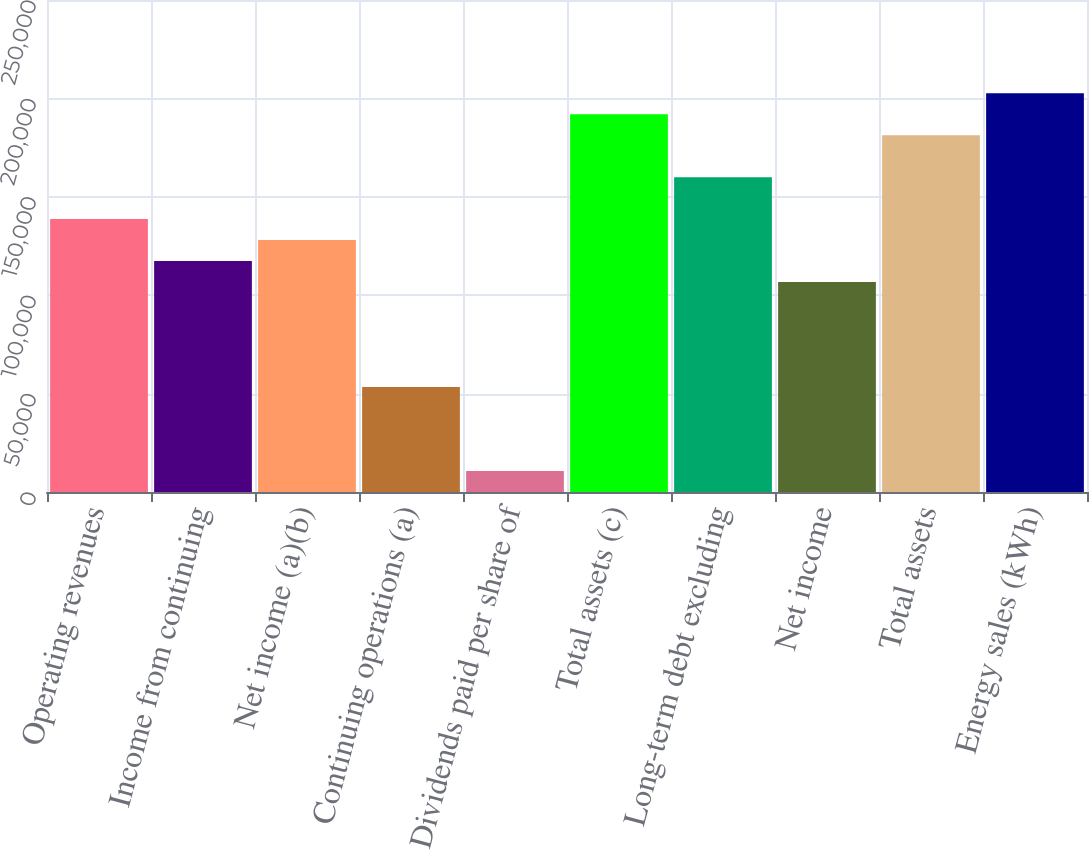Convert chart. <chart><loc_0><loc_0><loc_500><loc_500><bar_chart><fcel>Operating revenues<fcel>Income from continuing<fcel>Net income (a)(b)<fcel>Continuing operations (a)<fcel>Dividends paid per share of<fcel>Total assets (c)<fcel>Long-term debt excluding<fcel>Net income<fcel>Total assets<fcel>Energy sales (kWh)<nl><fcel>138660<fcel>117328<fcel>127994<fcel>53331.4<fcel>10667<fcel>191991<fcel>159993<fcel>106662<fcel>181325<fcel>202657<nl></chart> 